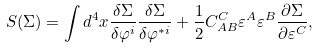Convert formula to latex. <formula><loc_0><loc_0><loc_500><loc_500>S ( \Sigma ) = \int d ^ { 4 } x \frac { \delta \Sigma } { \delta \varphi ^ { i } } \frac { \delta \Sigma } { \delta \varphi ^ { * i } } + \frac { 1 } { 2 } C _ { A B } ^ { C } \varepsilon ^ { A } \varepsilon ^ { B } \frac { \partial \Sigma } { \partial \varepsilon ^ { C } } ,</formula> 